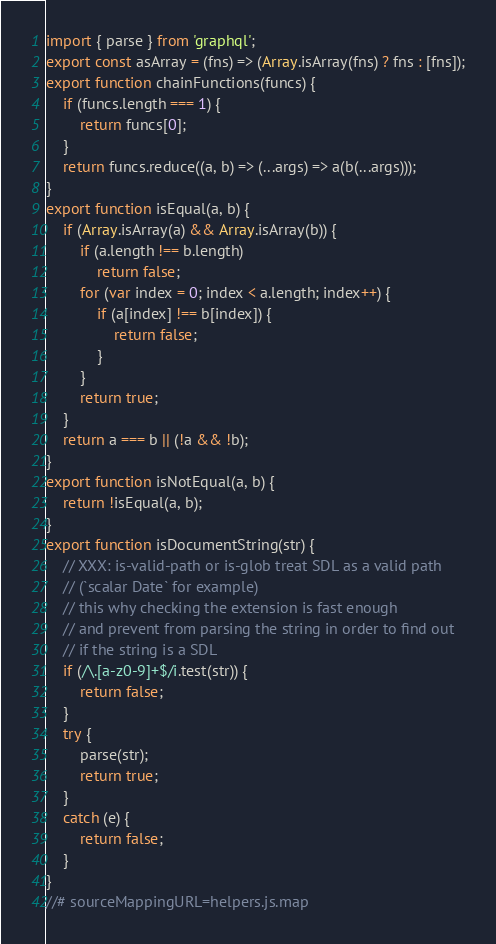<code> <loc_0><loc_0><loc_500><loc_500><_JavaScript_>import { parse } from 'graphql';
export const asArray = (fns) => (Array.isArray(fns) ? fns : [fns]);
export function chainFunctions(funcs) {
    if (funcs.length === 1) {
        return funcs[0];
    }
    return funcs.reduce((a, b) => (...args) => a(b(...args)));
}
export function isEqual(a, b) {
    if (Array.isArray(a) && Array.isArray(b)) {
        if (a.length !== b.length)
            return false;
        for (var index = 0; index < a.length; index++) {
            if (a[index] !== b[index]) {
                return false;
            }
        }
        return true;
    }
    return a === b || (!a && !b);
}
export function isNotEqual(a, b) {
    return !isEqual(a, b);
}
export function isDocumentString(str) {
    // XXX: is-valid-path or is-glob treat SDL as a valid path
    // (`scalar Date` for example)
    // this why checking the extension is fast enough
    // and prevent from parsing the string in order to find out
    // if the string is a SDL
    if (/\.[a-z0-9]+$/i.test(str)) {
        return false;
    }
    try {
        parse(str);
        return true;
    }
    catch (e) {
        return false;
    }
}
//# sourceMappingURL=helpers.js.map</code> 